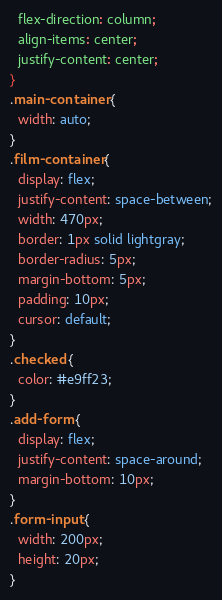<code> <loc_0><loc_0><loc_500><loc_500><_CSS_>  flex-direction: column;
  align-items: center;
  justify-content: center;
}
.main-container {
  width: auto;
}
.film-container {
  display: flex;
  justify-content: space-between;
  width: 470px;
  border: 1px solid lightgray;
  border-radius: 5px;
  margin-bottom: 5px;
  padding: 10px;
  cursor: default;
}
.checked {
  color: #e9ff23;
}
.add-form {
  display: flex;
  justify-content: space-around;
  margin-bottom: 10px;
}
.form-input {
  width: 200px;
  height: 20px;
}
</code> 